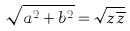Convert formula to latex. <formula><loc_0><loc_0><loc_500><loc_500>\sqrt { a ^ { 2 } + b ^ { 2 } } = \sqrt { z \overline { z } }</formula> 